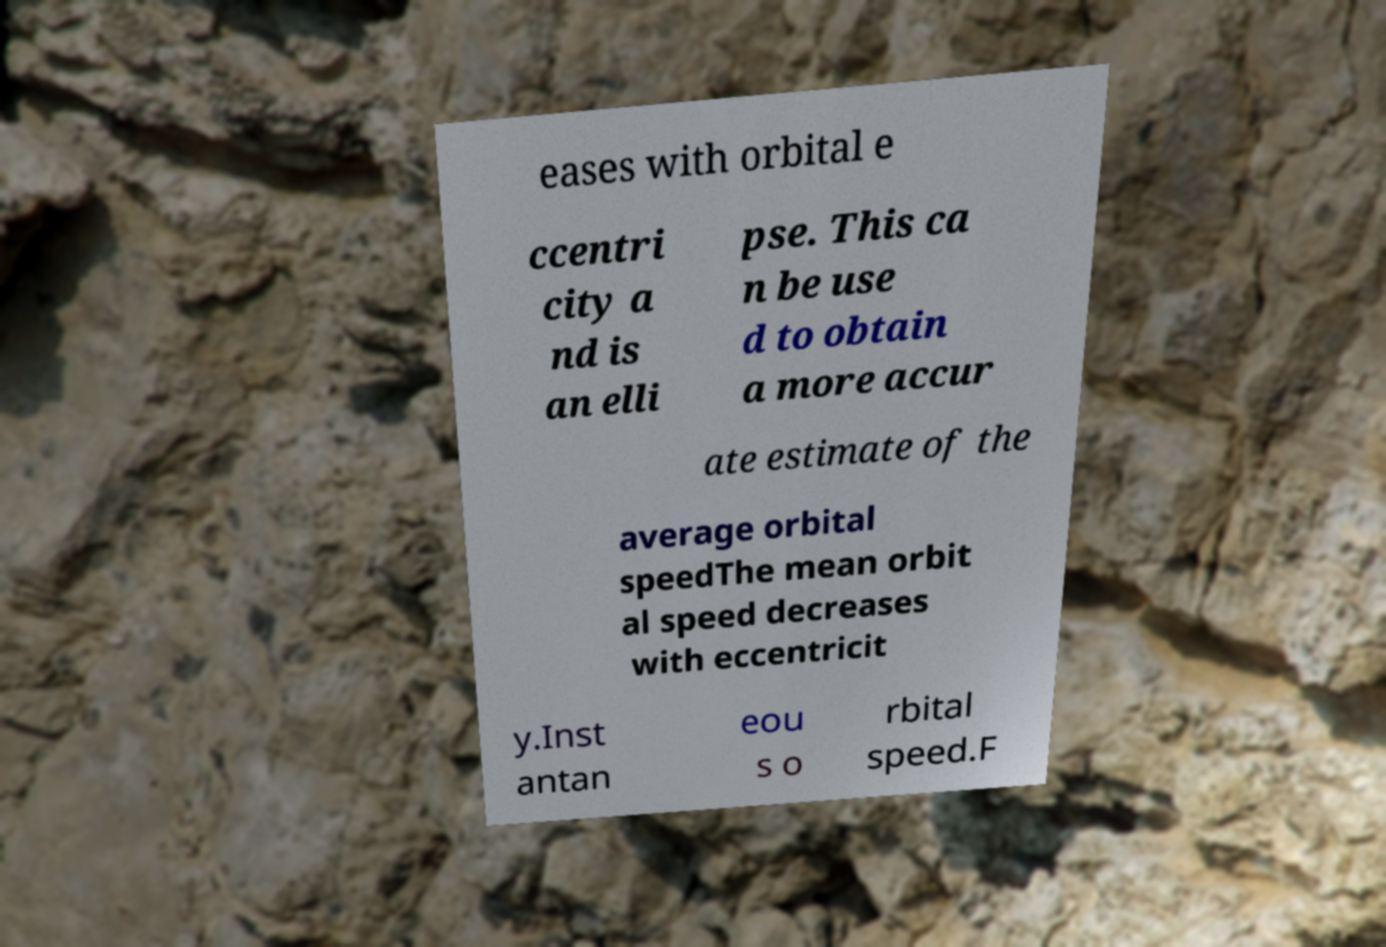Could you extract and type out the text from this image? eases with orbital e ccentri city a nd is an elli pse. This ca n be use d to obtain a more accur ate estimate of the average orbital speedThe mean orbit al speed decreases with eccentricit y.Inst antan eou s o rbital speed.F 